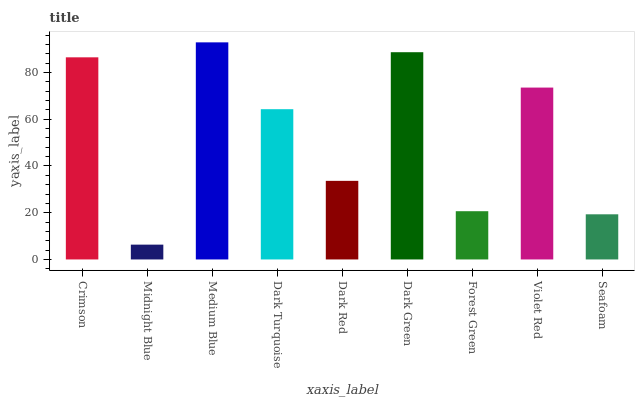Is Midnight Blue the minimum?
Answer yes or no. Yes. Is Medium Blue the maximum?
Answer yes or no. Yes. Is Medium Blue the minimum?
Answer yes or no. No. Is Midnight Blue the maximum?
Answer yes or no. No. Is Medium Blue greater than Midnight Blue?
Answer yes or no. Yes. Is Midnight Blue less than Medium Blue?
Answer yes or no. Yes. Is Midnight Blue greater than Medium Blue?
Answer yes or no. No. Is Medium Blue less than Midnight Blue?
Answer yes or no. No. Is Dark Turquoise the high median?
Answer yes or no. Yes. Is Dark Turquoise the low median?
Answer yes or no. Yes. Is Dark Green the high median?
Answer yes or no. No. Is Dark Red the low median?
Answer yes or no. No. 